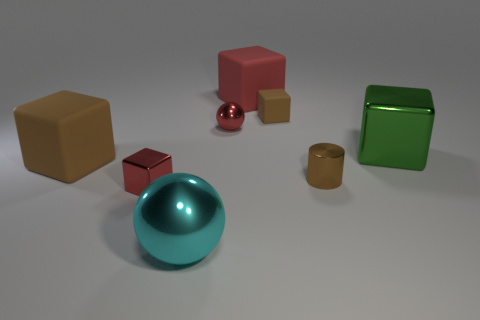Add 2 red blocks. How many objects exist? 10 Subtract all cubes. How many objects are left? 3 Add 6 matte things. How many matte things are left? 9 Add 3 small purple matte objects. How many small purple matte objects exist? 3 Subtract 0 blue balls. How many objects are left? 8 Subtract all tiny matte balls. Subtract all red matte cubes. How many objects are left? 7 